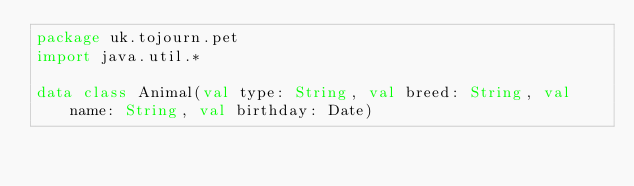Convert code to text. <code><loc_0><loc_0><loc_500><loc_500><_Kotlin_>package uk.tojourn.pet
import java.util.*

data class Animal(val type: String, val breed: String, val name: String, val birthday: Date)
</code> 